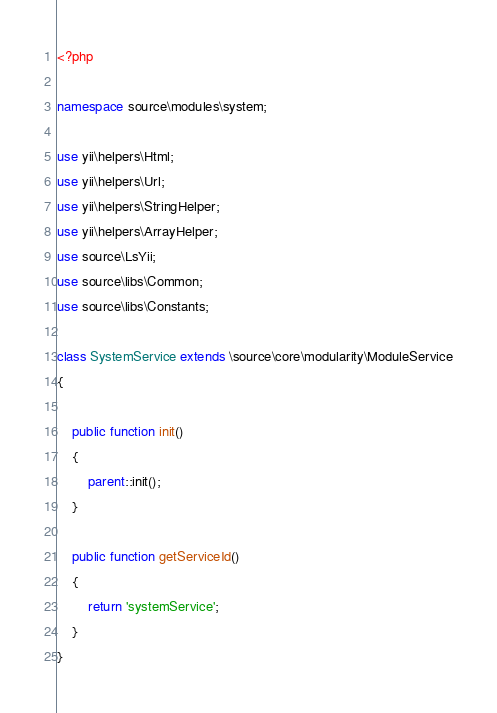Convert code to text. <code><loc_0><loc_0><loc_500><loc_500><_PHP_><?php

namespace source\modules\system;

use yii\helpers\Html;
use yii\helpers\Url;
use yii\helpers\StringHelper;
use yii\helpers\ArrayHelper;
use source\LsYii;
use source\libs\Common;
use source\libs\Constants;

class SystemService extends \source\core\modularity\ModuleService
{

    public function init()
    {
        parent::init();
    }
    
    public function getServiceId()
    {
        return 'systemService';
    }
}
</code> 